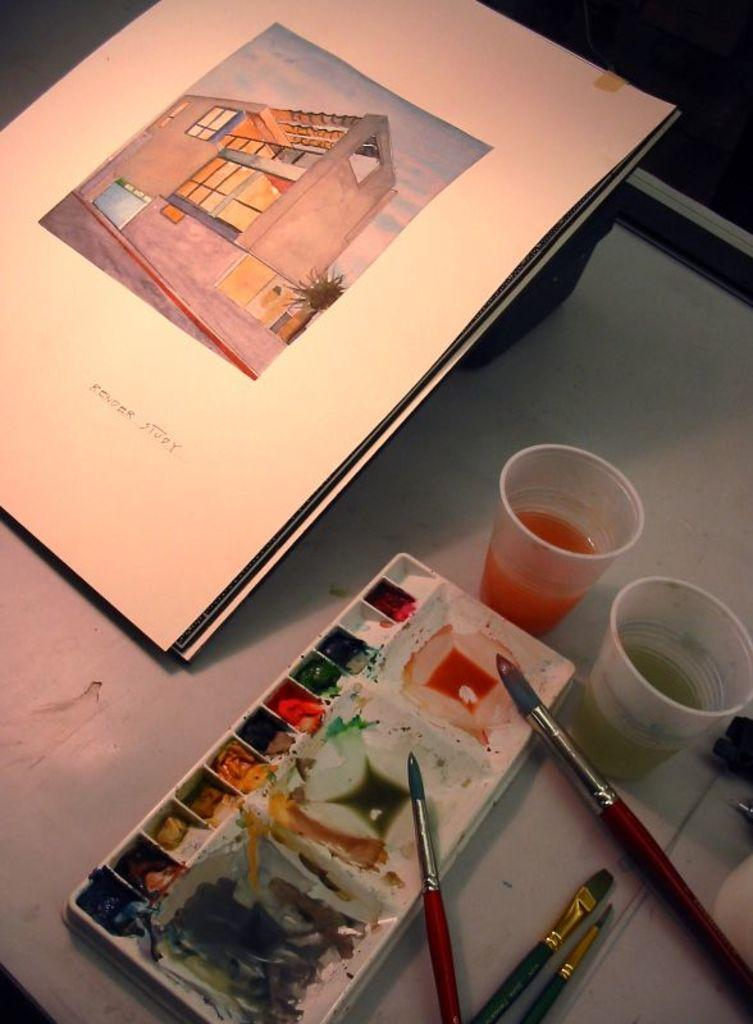What is the main piece of furniture in the image? There is a table in the image. What is placed on the table? There is a tray on the table. What items are contained within the tray? The tray contains colors, brushes, and glasses. What is located near the tray? There are papers to the side of the tray. What type of bone is visible on the table in the image? There is no bone present on the table in the image. What kind of apparatus is being used for milking the cows in the image? There are no cows or milking apparatus present in the image. 